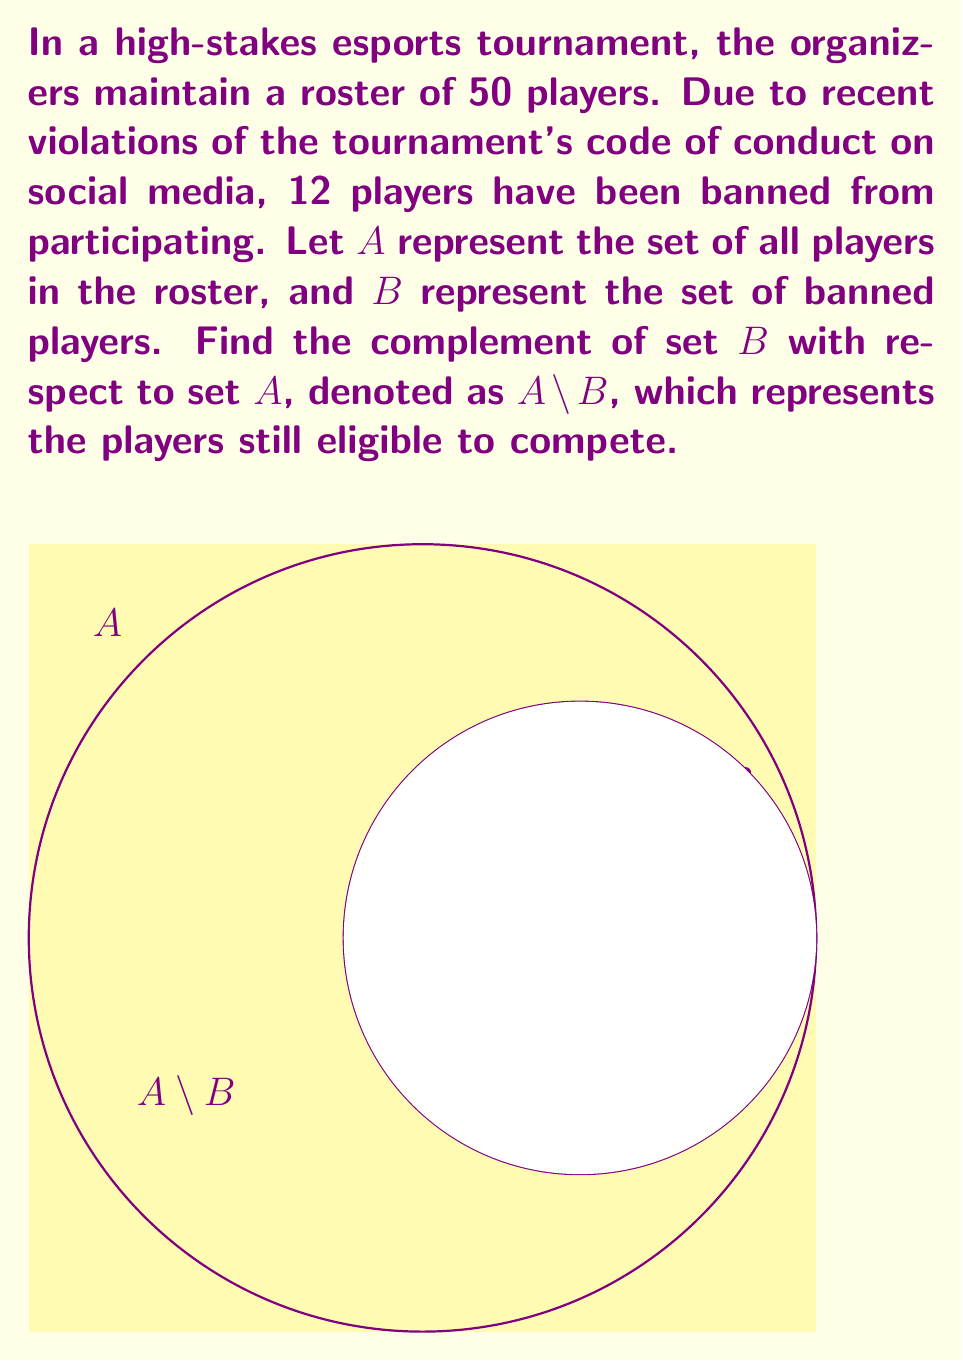Can you solve this math problem? To find the complement of set $B$ with respect to set $A$, we need to determine the elements that are in $A$ but not in $B$. This can be represented as $A \setminus B$.

Step 1: Identify the given information
- Total players in the roster (set $A$): 50
- Banned players (set $B$): 12

Step 2: Calculate the number of eligible players
The number of eligible players is the difference between the total players and the banned players.

$|A \setminus B| = |A| - |B|$
$|A \setminus B| = 50 - 12 = 38$

Therefore, there are 38 players still eligible to compete in the tournament.

Step 3: Interpret the result
The set $A \setminus B$ represents the players who are in the original roster but not in the set of banned players. These are the players who can still participate in the tournament without violating the code of conduct on social media.
Answer: $|A \setminus B| = 38$ 